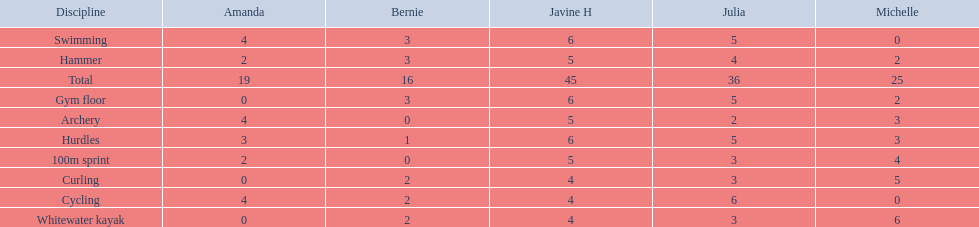What are the number of points bernie scored in hurdles? 1. 